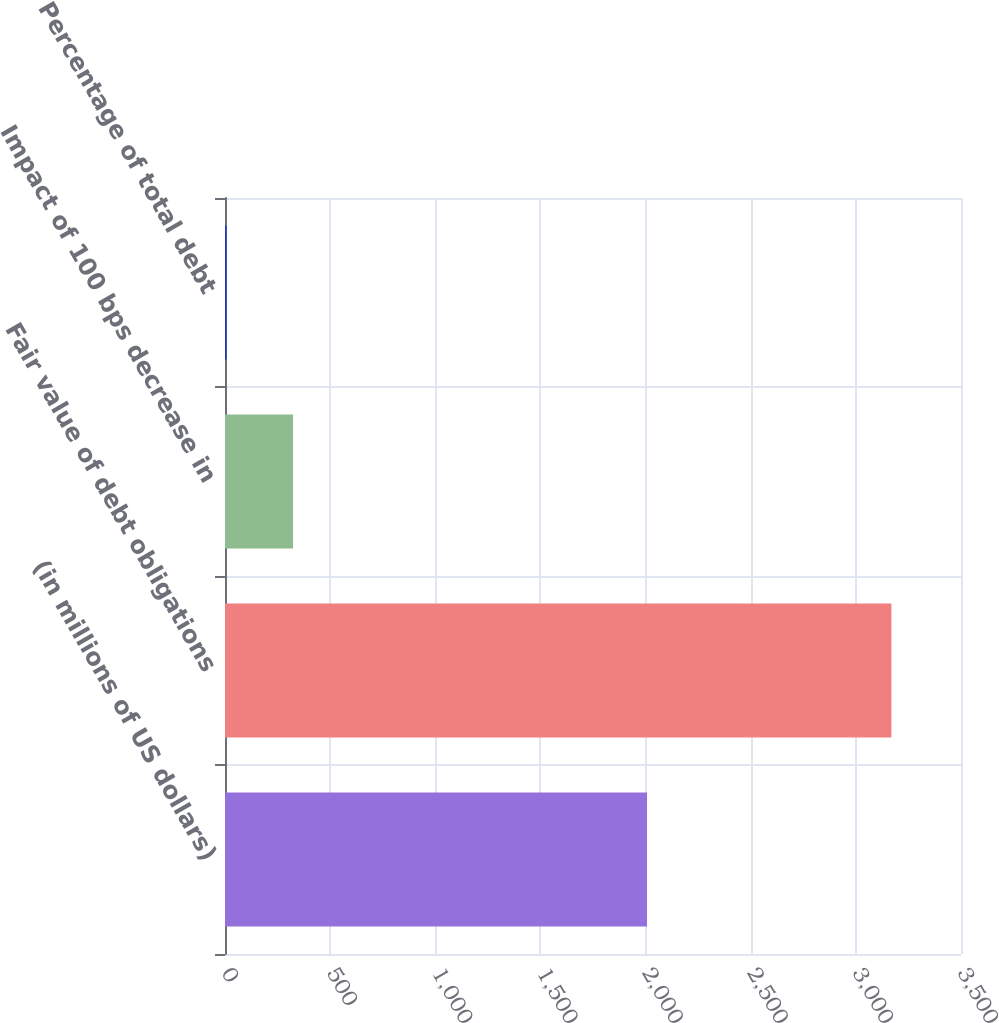Convert chart to OTSL. <chart><loc_0><loc_0><loc_500><loc_500><bar_chart><fcel>(in millions of US dollars)<fcel>Fair value of debt obligations<fcel>Impact of 100 bps decrease in<fcel>Percentage of total debt<nl><fcel>2007<fcel>3169<fcel>323.56<fcel>7.4<nl></chart> 